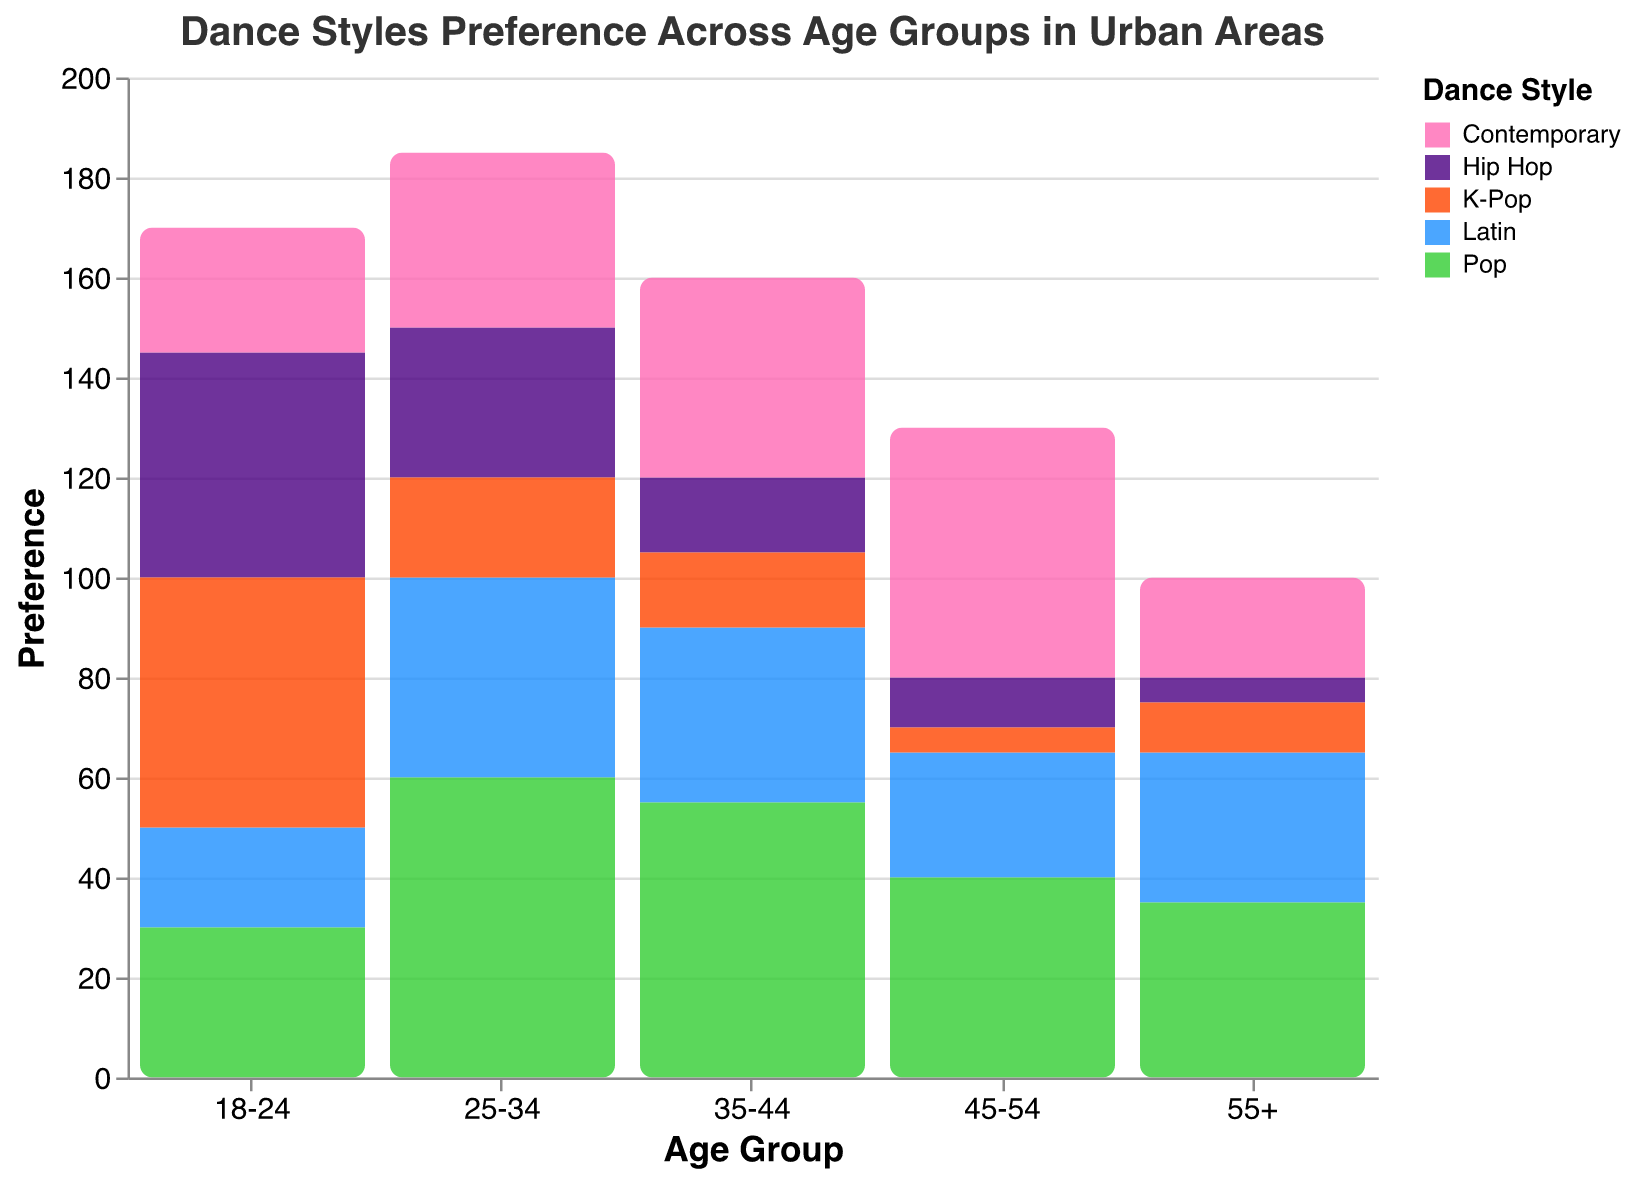What is the most preferred dance style among the 18-24 age group? By looking at the bar height for the 18-24 age group and comparing the colors associated with each dance style, the highest bar corresponds to K-Pop.
Answer: K-Pop Which age group has the highest preference for Hip Hop? By comparing the heights of the bars representing Hip Hop across all age groups, the 18-24 age group has the highest preference with a value of 45.
Answer: 18-24 How many more people in the 25-34 age group prefer Pop over Contemporary? Subtract the preference for Contemporary (35) from the preference for Pop (60) in the 25-34 age group. \(60 - 35 = 25\).
Answer: 25 What is the least preferred dance style among the 45-54 age group? By identifying the lowest bar for the 45-54 age group, K-Pop has the lowest preference with a value of 5.
Answer: K-Pop Compare the popularity of Contemporary dance style in the 18-24 and 35-44 age groups. Which age group prefers it more and by how much? The preference for Contemporary in the 18-24 age group is 25 and for the 35-44 age group is 40. Subtract the smaller value from the larger value: \(40 - 25 = 15\). The 35-44 age group prefers it more.
Answer: 35-44 by 15 Which age group shows the highest overall preference for dance styles combined? Sum the preferences for each age group and compare them. The 25-34 group's preferences sum up to 185 (30+35+40+60+20), which is the highest among all the age groups.
Answer: 25-34 What age group has the widest range in preferences for different dance styles? Calculate the range (difference between the highest and lowest preferences) for each age group. The 45-54 age group has the widest range: 50 (highest for Contemporary) - 5 (lowest for K-Pop) = 45.
Answer: 45-54 What is the most preferred dance style among the 55+ age group? By observing the heights of the bars for the 55+ age group, the highest bar corresponds to Pop with a preference of 35.
Answer: Pop How does the preference for Latin dance style change with age? By observing the heights of the bars for Latin dance style across age groups, preference increases from 18-24 (20) to 25-34 (40), then slightly decreases to 35-44 (35), drops to 25 in 45-54, and slightly increases again to 30 in 55+.
Answer: Generally, increases, then decreases, followed by a slight increase What is the difference in preference for K-Pop between the 18-24 and 55+ age groups? Subtract the preference for K-Pop in the 55+ age group (10) from the preference in the 18-24 age group (50): \(50 - 10 = 40\).
Answer: 40 